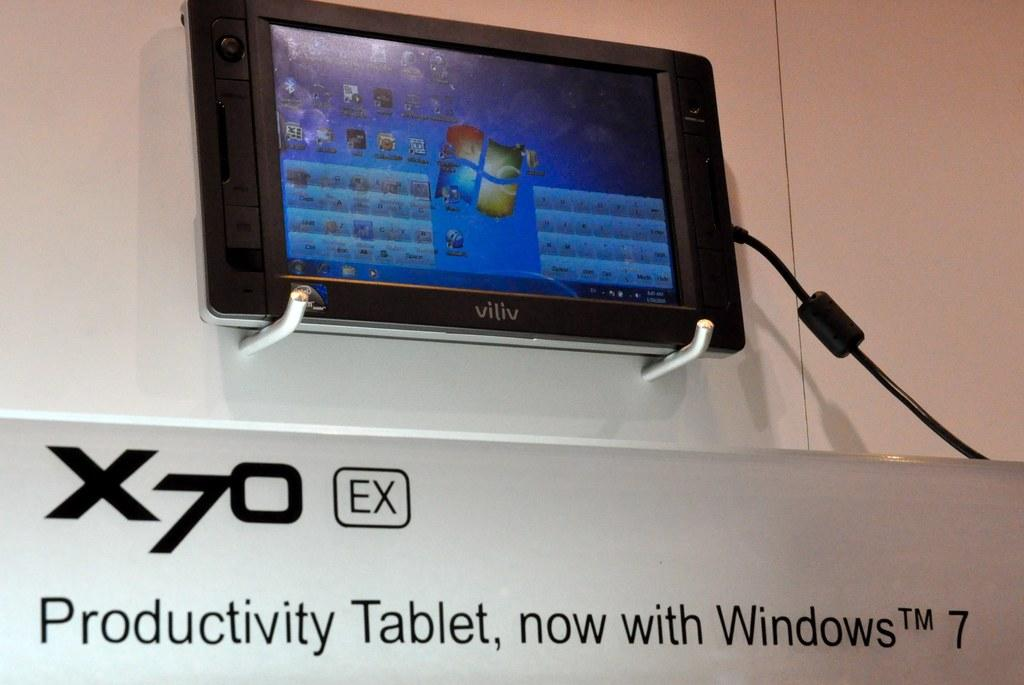What type of electronic device is on the wall in the image? There is an electronic gadget on the wall in the image. Can you describe any other visible elements in the image? Yes, there is a wire visible in the image. What is the main object in the front of the image? There is a board in the front of the image. Can you tell me how many flowers are on the board in the image? There are no flowers present on the board in the image. What type of fold can be seen in the wire in the image? There is no fold in the wire in the image; it appears to be a straight wire. 